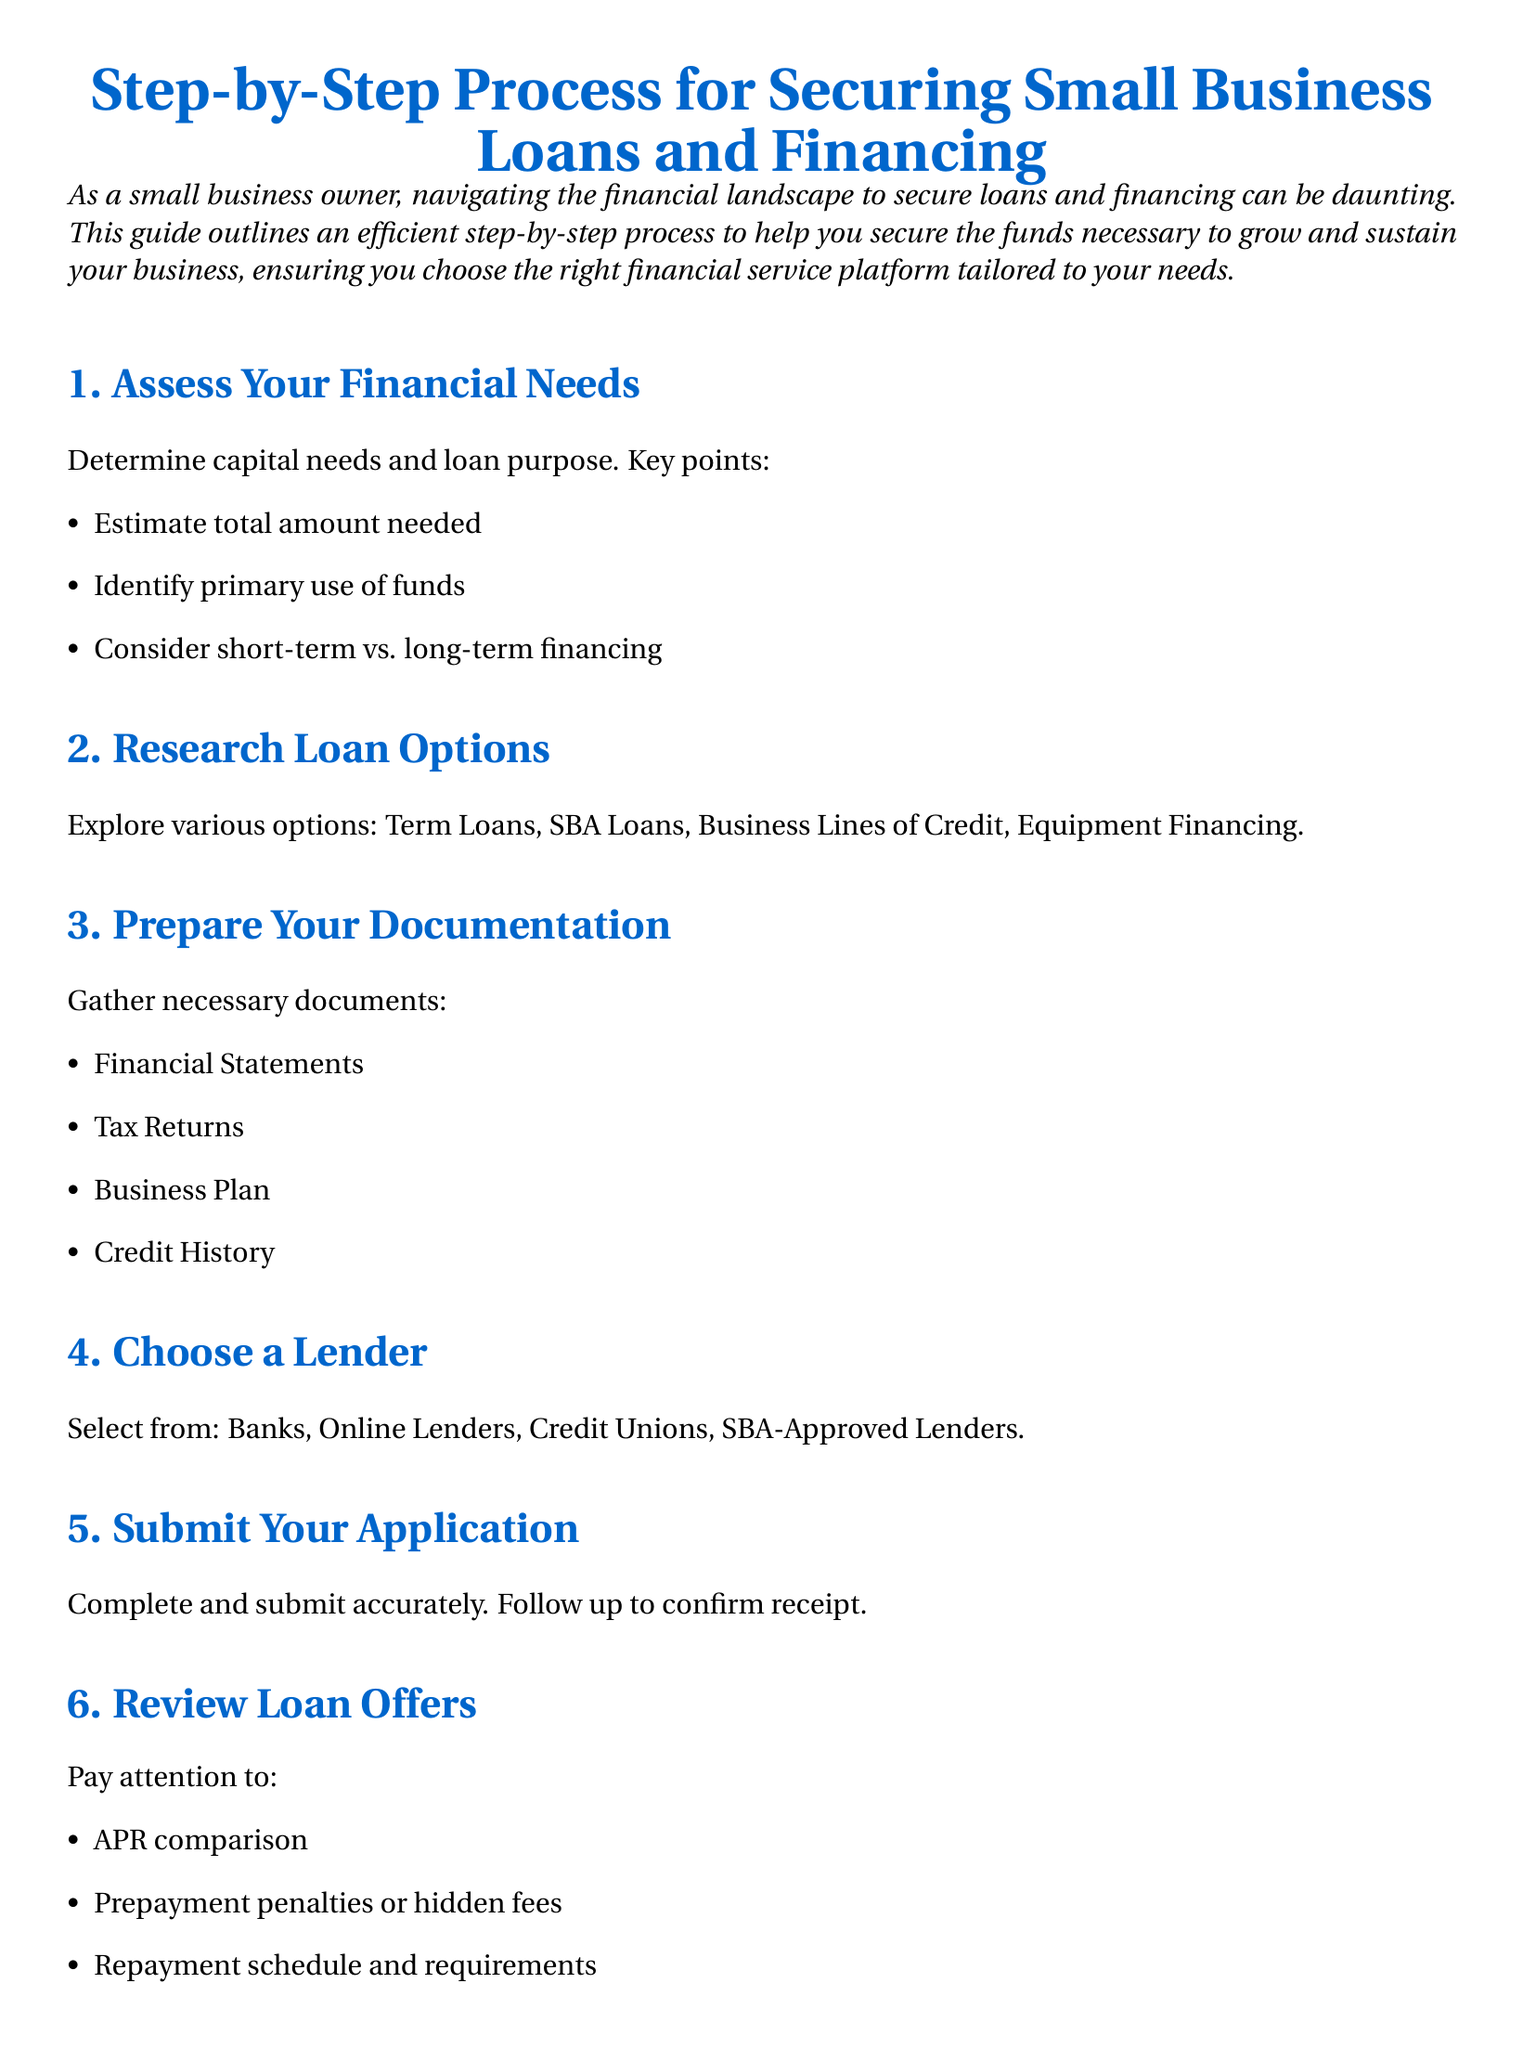What is the first step in securing a small business loan? The first step outlined in the document is to assess your financial needs.
Answer: Assess Your Financial Needs What types of loan options are mentioned? The document lists specific loan options in section 2, including Term Loans and SBA Loans.
Answer: Term Loans, SBA Loans, Business Lines of Credit, Equipment Financing What documents do you need to prepare? The necessary documents to gather are listed in section 3 of the document.
Answer: Financial Statements, Tax Returns, Business Plan, Credit History What should you compare when reviewing loan offers? Key points to consider when reviewing loan offers are detailed in section 6 and include multiple factors.
Answer: APR comparison, Prepayment penalties or hidden fees, Repayment schedule and requirements Who can be a lender? The document outlines potential lenders in section 4 and specifies several types.
Answer: Banks, Online Lenders, Credit Unions, SBA-Approved Lenders What is emphasized regarding the use of funds after receiving a loan? The last section warns about how to manage funds and emphasizes using them correctly.
Answer: Use funds as outlined in business plan How many total steps are there in the loan securing process? The structured list in the document indicates the total number of steps provided for securing loans.
Answer: 7 